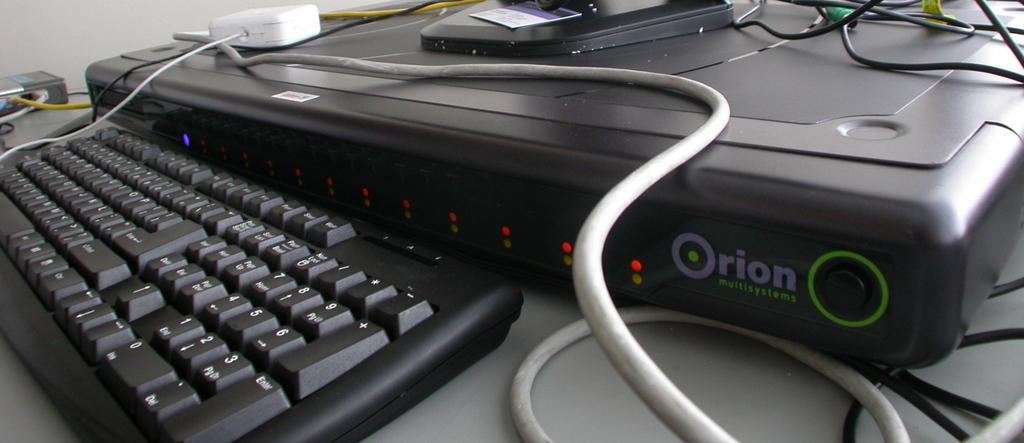<image>
Give a short and clear explanation of the subsequent image. a black key board and computer reading ORION Multisystems 